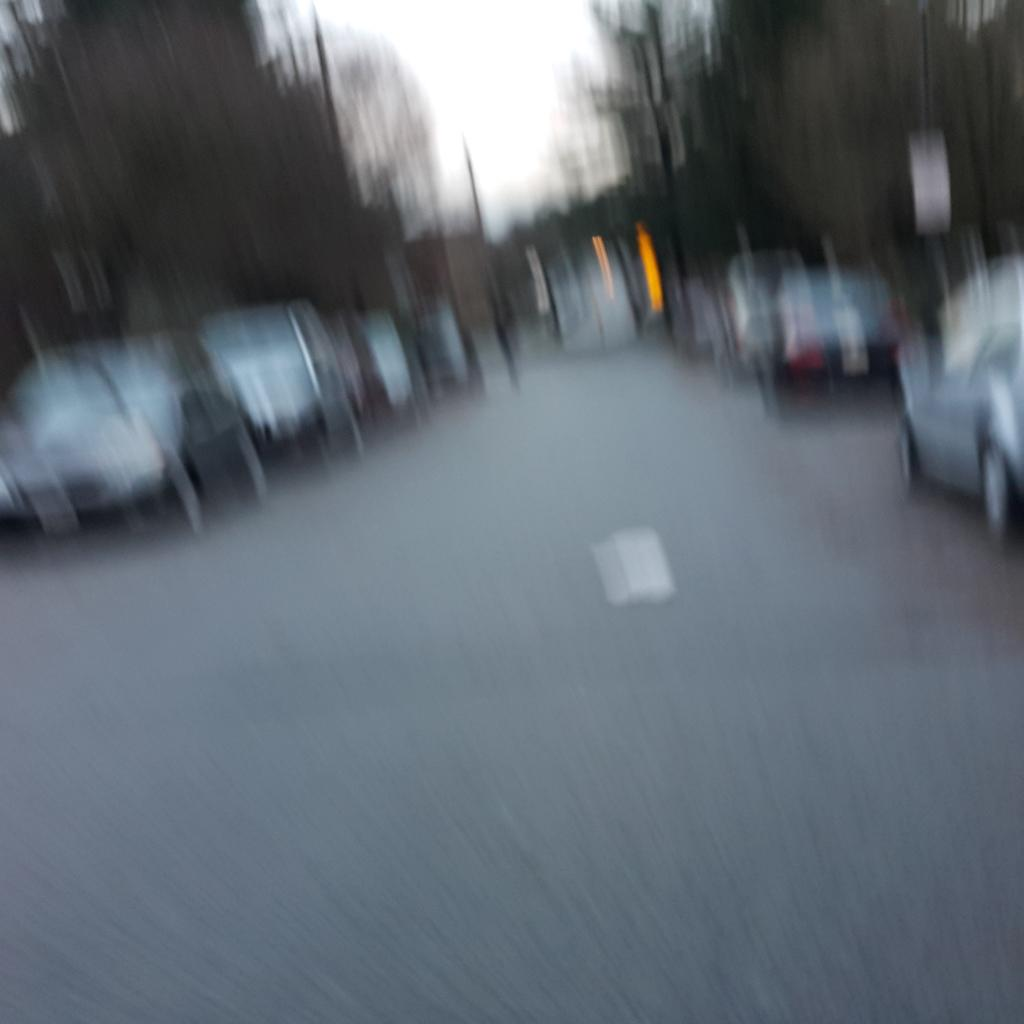What is the main subject of the image? The main subject of the image is a group of cars. Are there any other objects or elements in the image besides the cars? Yes, there is a tree and the sky is visible at the top of the image. How would you describe the quality of the image? The image is slightly blurred. What thought does the mother have while walking on the sidewalk in the image? There is no mother or sidewalk present in the image, so it is not possible to answer that question. 